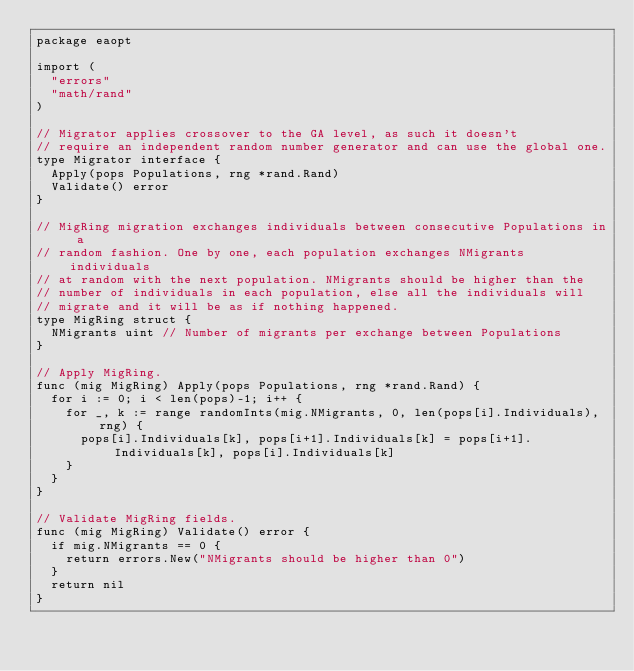<code> <loc_0><loc_0><loc_500><loc_500><_Go_>package eaopt

import (
	"errors"
	"math/rand"
)

// Migrator applies crossover to the GA level, as such it doesn't
// require an independent random number generator and can use the global one.
type Migrator interface {
	Apply(pops Populations, rng *rand.Rand)
	Validate() error
}

// MigRing migration exchanges individuals between consecutive Populations in a
// random fashion. One by one, each population exchanges NMigrants individuals
// at random with the next population. NMigrants should be higher than the
// number of individuals in each population, else all the individuals will
// migrate and it will be as if nothing happened.
type MigRing struct {
	NMigrants uint // Number of migrants per exchange between Populations
}

// Apply MigRing.
func (mig MigRing) Apply(pops Populations, rng *rand.Rand) {
	for i := 0; i < len(pops)-1; i++ {
		for _, k := range randomInts(mig.NMigrants, 0, len(pops[i].Individuals), rng) {
			pops[i].Individuals[k], pops[i+1].Individuals[k] = pops[i+1].Individuals[k], pops[i].Individuals[k]
		}
	}
}

// Validate MigRing fields.
func (mig MigRing) Validate() error {
	if mig.NMigrants == 0 {
		return errors.New("NMigrants should be higher than 0")
	}
	return nil
}
</code> 